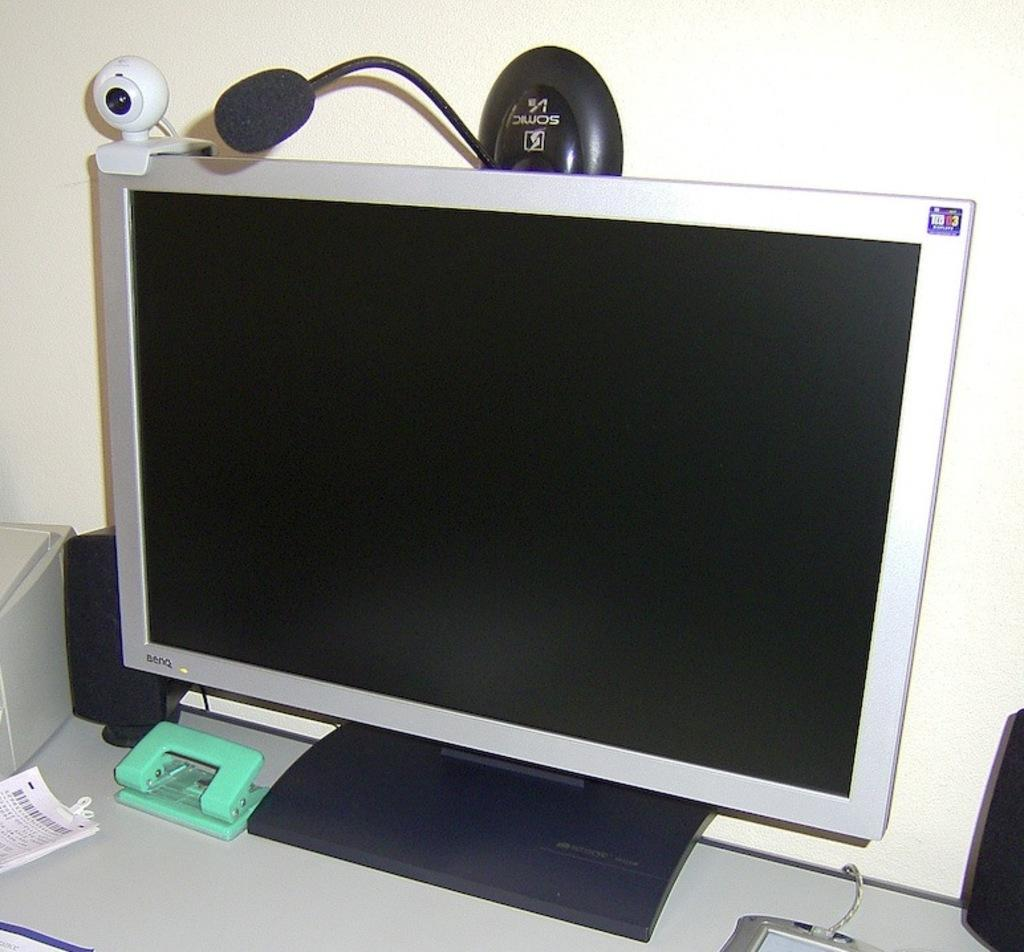<image>
Describe the image concisely. A sticker in the upper right corner of a monitor screen says "03". 